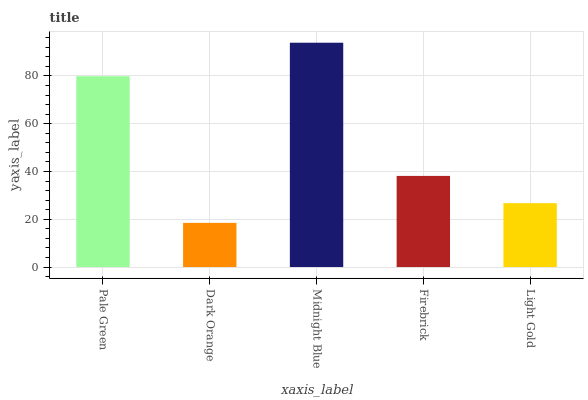Is Midnight Blue the minimum?
Answer yes or no. No. Is Dark Orange the maximum?
Answer yes or no. No. Is Midnight Blue greater than Dark Orange?
Answer yes or no. Yes. Is Dark Orange less than Midnight Blue?
Answer yes or no. Yes. Is Dark Orange greater than Midnight Blue?
Answer yes or no. No. Is Midnight Blue less than Dark Orange?
Answer yes or no. No. Is Firebrick the high median?
Answer yes or no. Yes. Is Firebrick the low median?
Answer yes or no. Yes. Is Midnight Blue the high median?
Answer yes or no. No. Is Light Gold the low median?
Answer yes or no. No. 